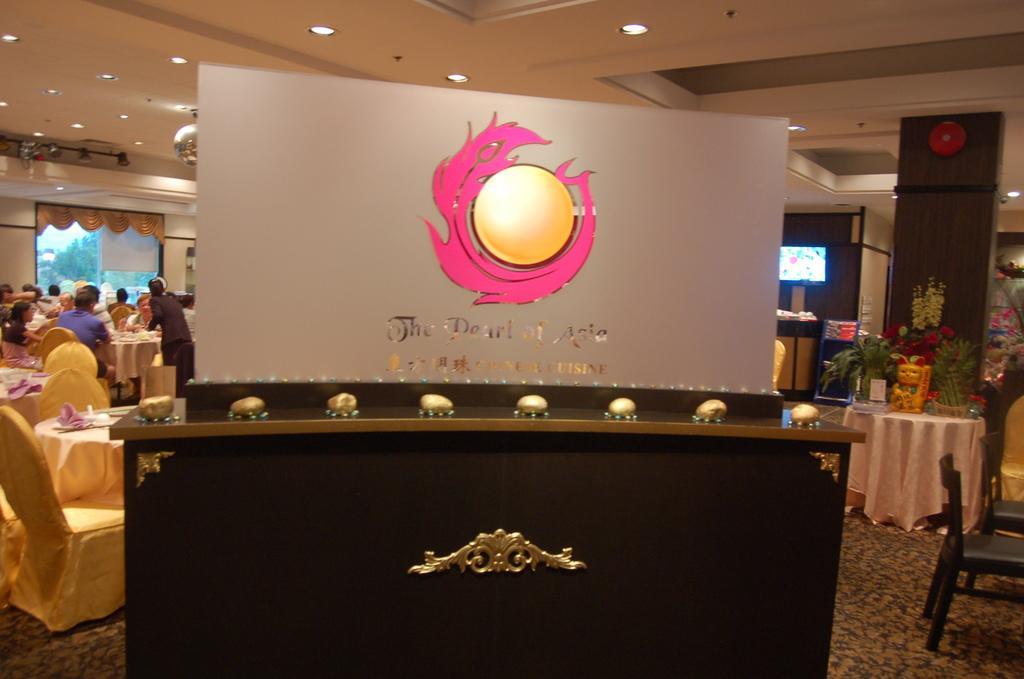Please provide a concise description of this image. In the image we can see there is a table on which there is a banner kept and at the back people are sitting on the chairs. 